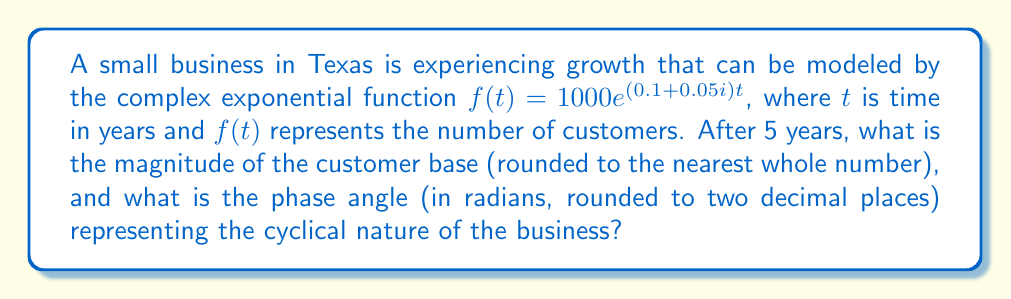Could you help me with this problem? To solve this problem, we need to evaluate the complex exponential function at $t = 5$ and then convert the result to polar form.

1) First, let's evaluate $f(5)$:
   $f(5) = 1000e^{(0.1 + 0.05i)5}$
   $f(5) = 1000e^{0.5 + 0.25i}$

2) Now, we can use Euler's formula: $e^{a+bi} = e^a(\cos b + i\sin b)$
   $f(5) = 1000e^{0.5}(\cos 0.25 + i\sin 0.25)$

3) Calculate $e^{0.5}$:
   $e^{0.5} \approx 1.6487$

4) Therefore:
   $f(5) \approx 1648.7(\cos 0.25 + i\sin 0.25)$

5) To find the magnitude, we use $|z| = \sqrt{a^2 + b^2}$ where $z = a + bi$:
   $|f(5)| \approx 1648.7\sqrt{\cos^2 0.25 + \sin^2 0.25} = 1648.7$

6) To find the phase angle, we use $\arg(z) = \arctan(\frac{b}{a})$:
   $\arg(f(5)) = \arctan(\frac{\sin 0.25}{\cos 0.25}) = 0.25$

The magnitude represents the total number of customers, while the phase angle represents the cyclical nature of the business.
Answer: The magnitude of the customer base after 5 years is approximately 1649 customers, and the phase angle is 0.25 radians. 